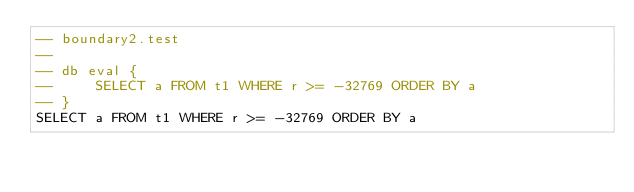Convert code to text. <code><loc_0><loc_0><loc_500><loc_500><_SQL_>-- boundary2.test
-- 
-- db eval {
--     SELECT a FROM t1 WHERE r >= -32769 ORDER BY a
-- }
SELECT a FROM t1 WHERE r >= -32769 ORDER BY a</code> 